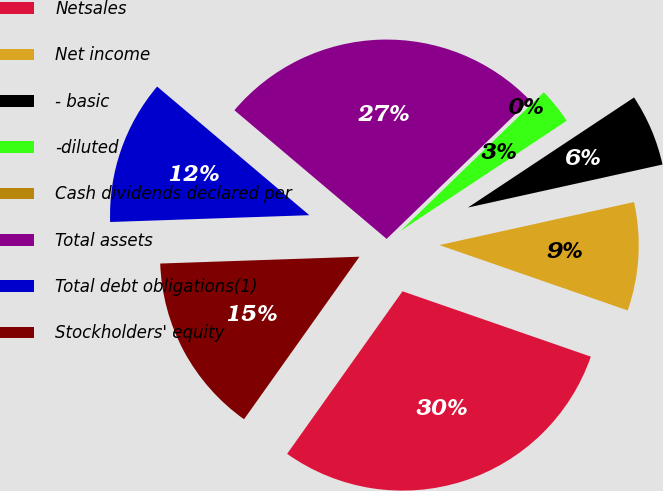Convert chart to OTSL. <chart><loc_0><loc_0><loc_500><loc_500><pie_chart><fcel>Netsales<fcel>Net income<fcel>- basic<fcel>-diluted<fcel>Cash dividends declared per<fcel>Total assets<fcel>Total debt obligations(1)<fcel>Stockholders' equity<nl><fcel>29.51%<fcel>8.78%<fcel>5.85%<fcel>2.93%<fcel>0.0%<fcel>26.59%<fcel>11.71%<fcel>14.63%<nl></chart> 